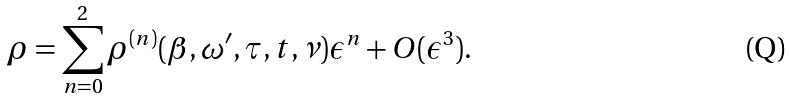Convert formula to latex. <formula><loc_0><loc_0><loc_500><loc_500>\rho = \sum _ { n = 0 } ^ { 2 } \rho ^ { ( n ) } ( \beta , \omega ^ { \prime } , \tau , t , \nu ) \epsilon ^ { n } + O ( \epsilon ^ { 3 } ) .</formula> 